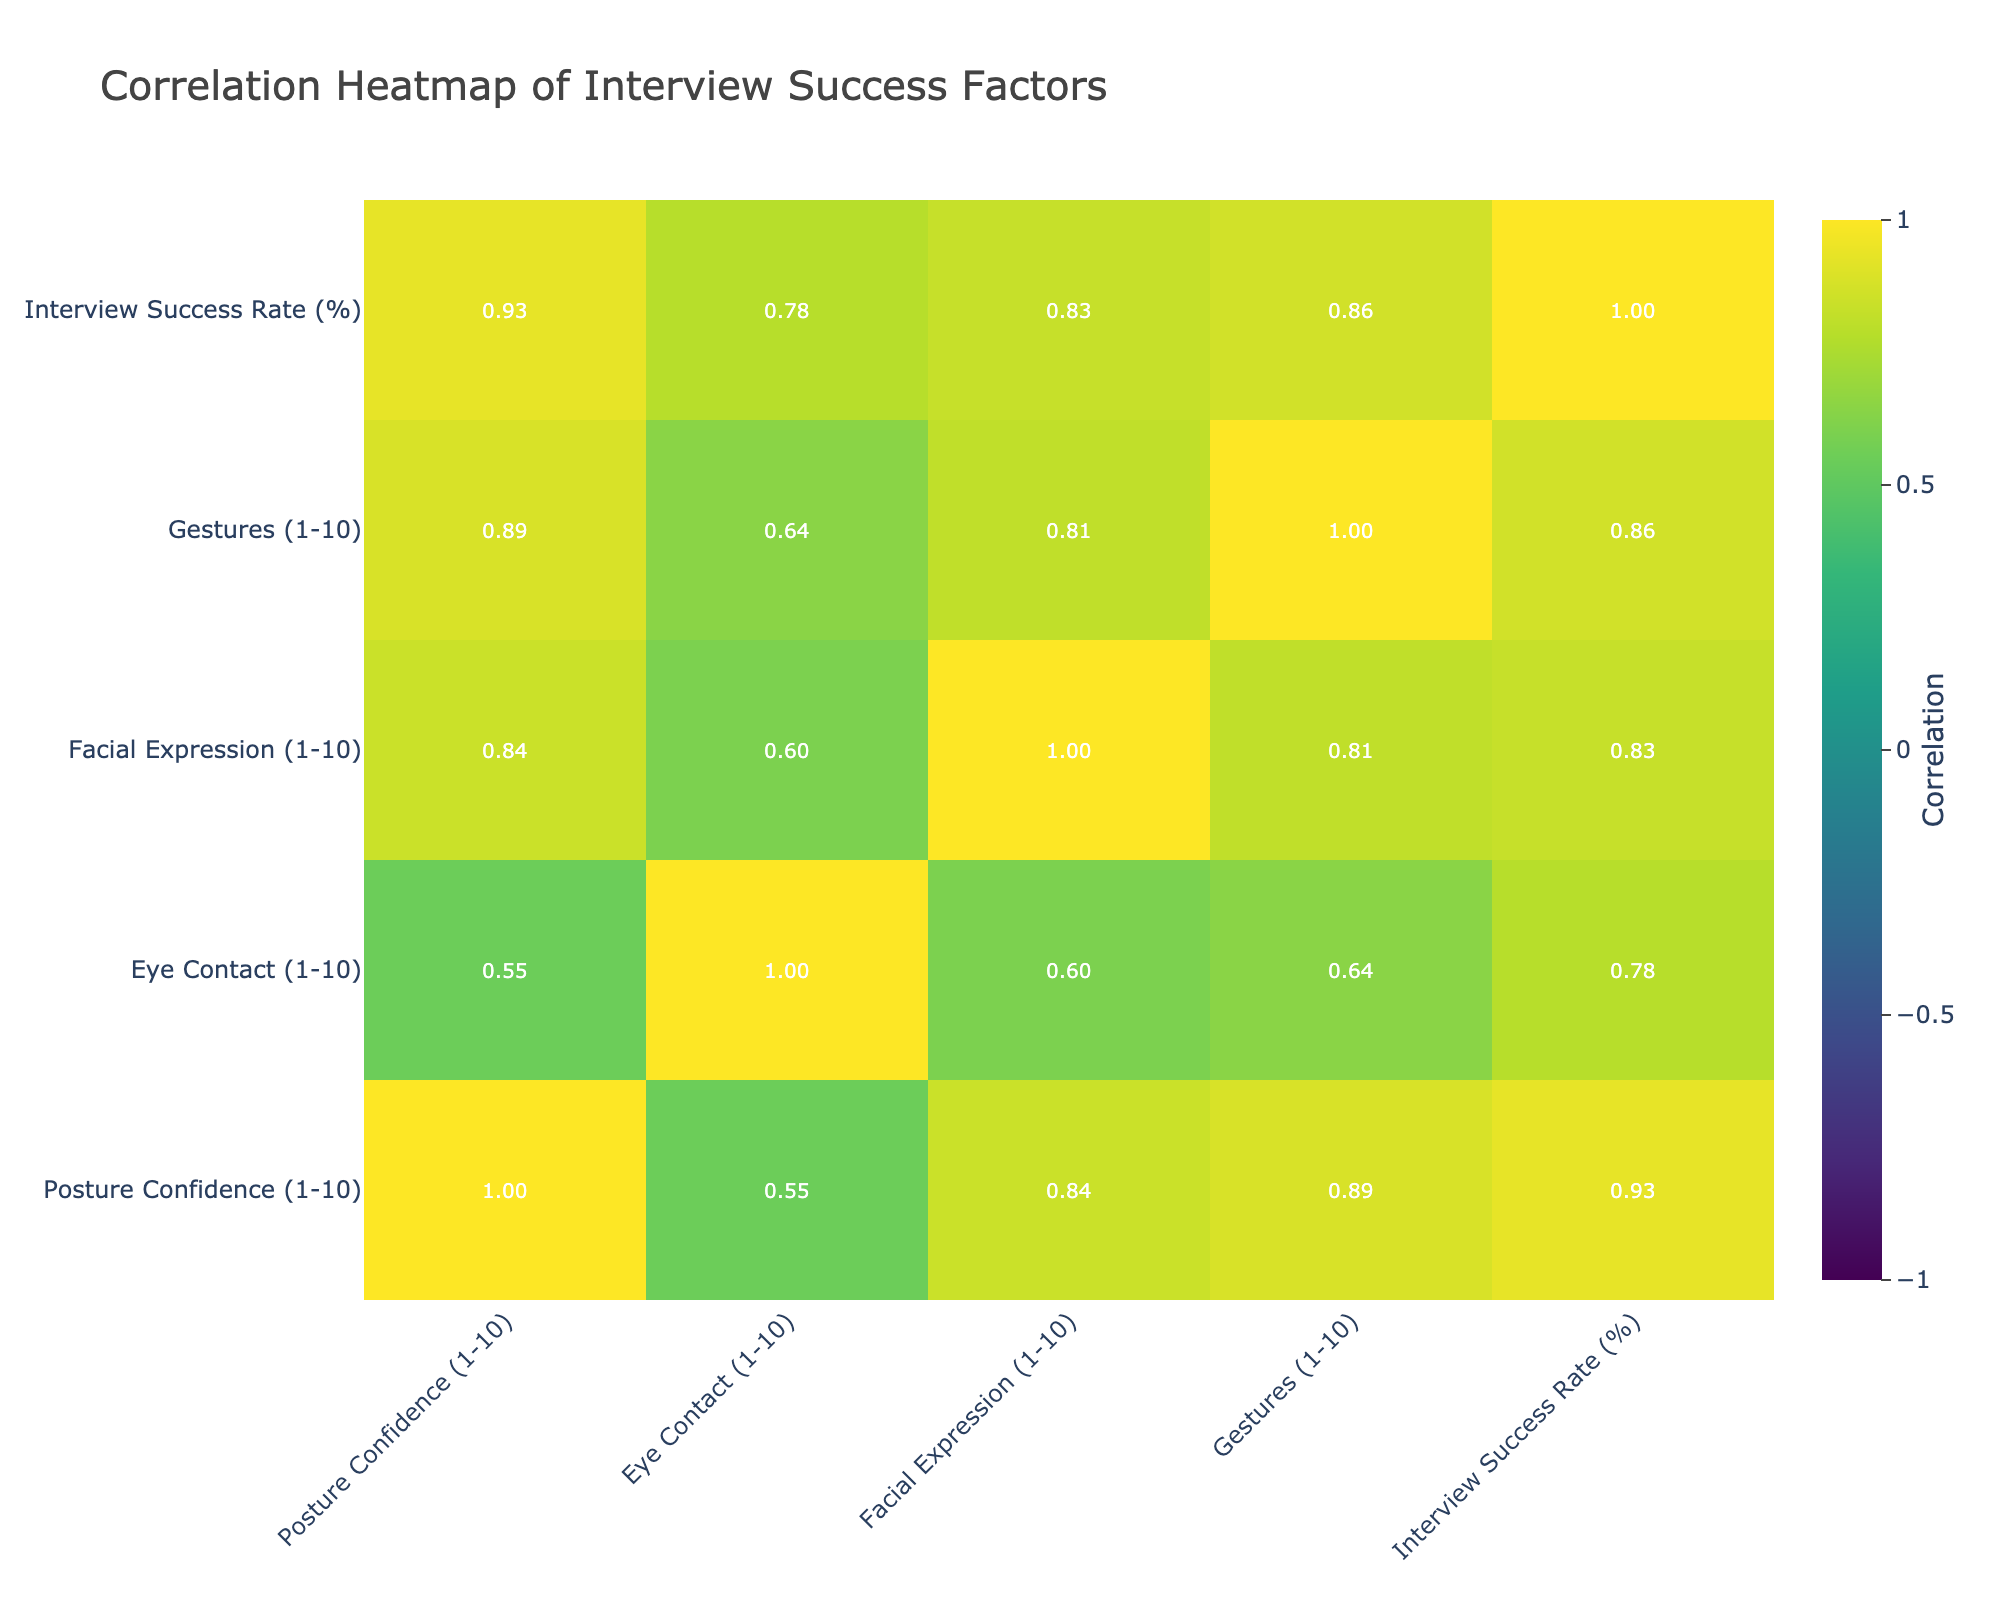What is the interview success rate for German? From the table, the success rate for the German language is listed as 90%.
Answer: 90% Which language demonstrates the highest confidence in posture? By looking at the posture confidence ratings, the highest value is 9, associated with the German language.
Answer: German What is the average eye contact score across all languages? To find the average, we sum the eye contact scores (9 + 8 + 7 + 8 + 7 + 6 + 5 + 6 + 8 + 9 + 6 + 5) = 7.25. There are 12 languages, so dividing 87 by 12 gives an average of 7.25.
Answer: 7.25 True or False: Hindi has a higher success rate than Arabic. Hindi has an interview success rate of 78%, while Arabic has 77%. Since 78% is greater than 77%, the statement is true.
Answer: True What is the difference in success rates between English and Mandarin? English has a success rate of 85% and Mandarin has 75%. The difference can be calculated as 85% - 75% = 10%.
Answer: 10% Which language has the lowest score for facial expression? The Mandarin language has the lowest score for facial expression, which is 6.
Answer: Mandarin How many languages have a posture confidence score of 7 or above? The languages with a posture confidence score of 7 or higher are English, Spanish, German, Italian, and Portuguese. This totals to 5 languages.
Answer: 5 Is there a correlation between eye contact and interview success? The correlation value between eye contact and interview success can be seen in the correlation table, which indicates a positive or negative correlation value. After examining the matrix, eye contact and success have a correlation of 0.7, indicating a strong positive correlation.
Answer: Yes What is the language with the highest score for gestures? The Italian language has the highest score for gestures, which is 8.
Answer: Italian 